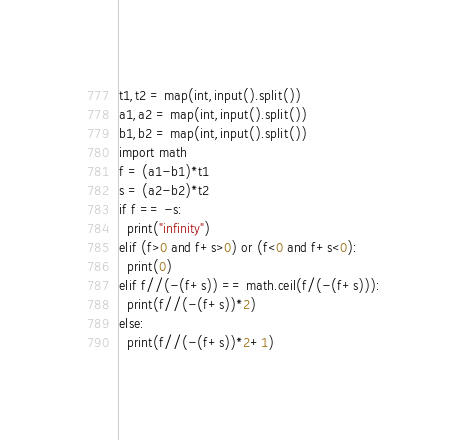Convert code to text. <code><loc_0><loc_0><loc_500><loc_500><_Python_>t1,t2 = map(int,input().split())
a1,a2 = map(int,input().split())
b1,b2 = map(int,input().split())
import math
f = (a1-b1)*t1
s = (a2-b2)*t2
if f == -s:
  print("infinity")
elif (f>0 and f+s>0) or (f<0 and f+s<0):
  print(0)
elif f//(-(f+s)) == math.ceil(f/(-(f+s))):
  print(f//(-(f+s))*2)
else:
  print(f//(-(f+s))*2+1)</code> 